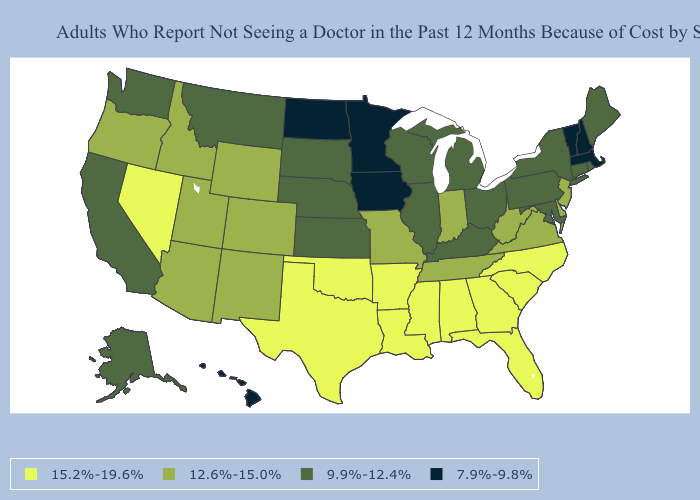What is the value of Iowa?
Write a very short answer. 7.9%-9.8%. Which states hav the highest value in the South?
Concise answer only. Alabama, Arkansas, Florida, Georgia, Louisiana, Mississippi, North Carolina, Oklahoma, South Carolina, Texas. What is the highest value in the MidWest ?
Give a very brief answer. 12.6%-15.0%. How many symbols are there in the legend?
Write a very short answer. 4. Name the states that have a value in the range 7.9%-9.8%?
Quick response, please. Hawaii, Iowa, Massachusetts, Minnesota, New Hampshire, North Dakota, Vermont. Name the states that have a value in the range 9.9%-12.4%?
Be succinct. Alaska, California, Connecticut, Illinois, Kansas, Kentucky, Maine, Maryland, Michigan, Montana, Nebraska, New York, Ohio, Pennsylvania, Rhode Island, South Dakota, Washington, Wisconsin. What is the lowest value in the USA?
Write a very short answer. 7.9%-9.8%. What is the value of Wyoming?
Keep it brief. 12.6%-15.0%. Name the states that have a value in the range 9.9%-12.4%?
Quick response, please. Alaska, California, Connecticut, Illinois, Kansas, Kentucky, Maine, Maryland, Michigan, Montana, Nebraska, New York, Ohio, Pennsylvania, Rhode Island, South Dakota, Washington, Wisconsin. What is the value of Alabama?
Answer briefly. 15.2%-19.6%. Which states have the lowest value in the USA?
Concise answer only. Hawaii, Iowa, Massachusetts, Minnesota, New Hampshire, North Dakota, Vermont. Among the states that border Delaware , does Pennsylvania have the lowest value?
Short answer required. Yes. Does Kentucky have the lowest value in the South?
Answer briefly. Yes. How many symbols are there in the legend?
Give a very brief answer. 4. How many symbols are there in the legend?
Be succinct. 4. 